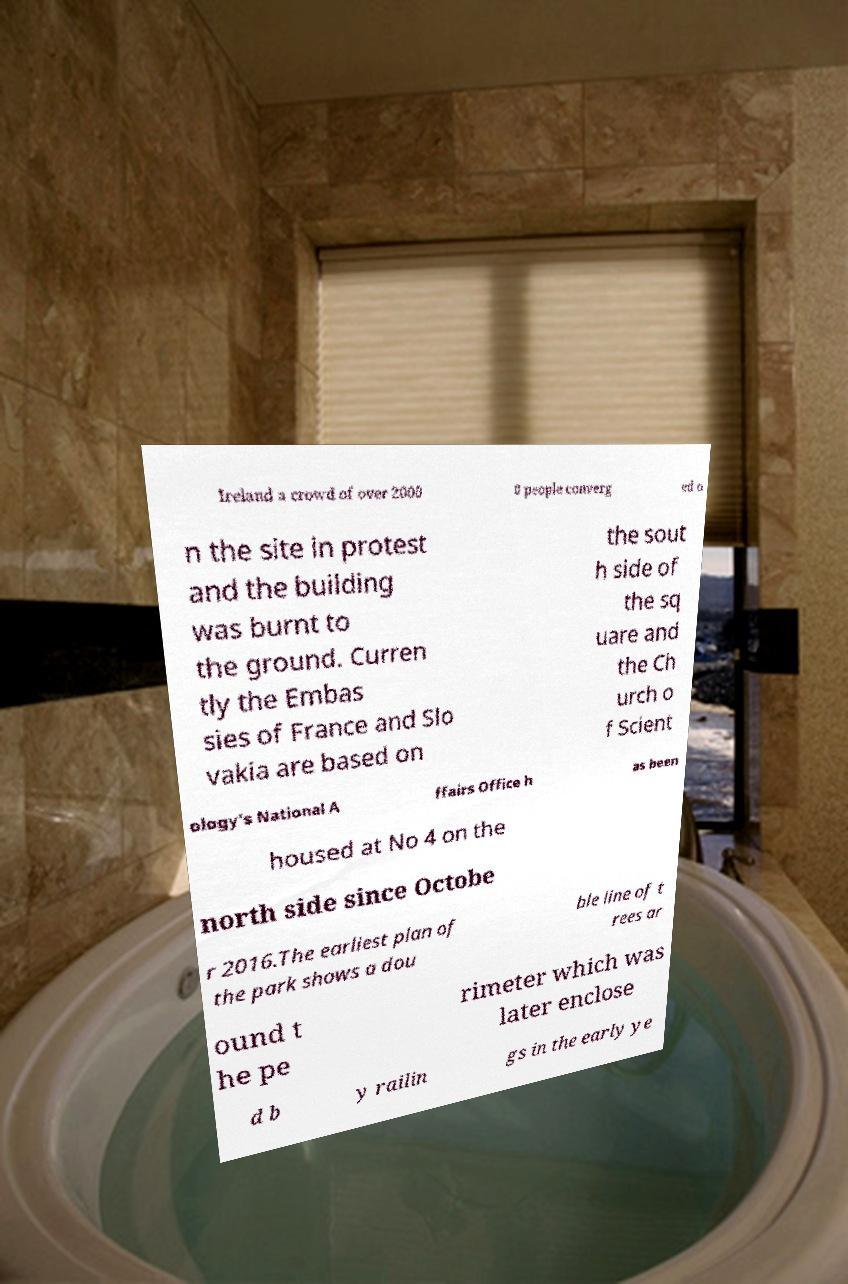Could you extract and type out the text from this image? Ireland a crowd of over 2000 0 people converg ed o n the site in protest and the building was burnt to the ground. Curren tly the Embas sies of France and Slo vakia are based on the sout h side of the sq uare and the Ch urch o f Scient ology's National A ffairs Office h as been housed at No 4 on the north side since Octobe r 2016.The earliest plan of the park shows a dou ble line of t rees ar ound t he pe rimeter which was later enclose d b y railin gs in the early ye 